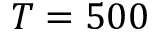<formula> <loc_0><loc_0><loc_500><loc_500>T = 5 0 0</formula> 